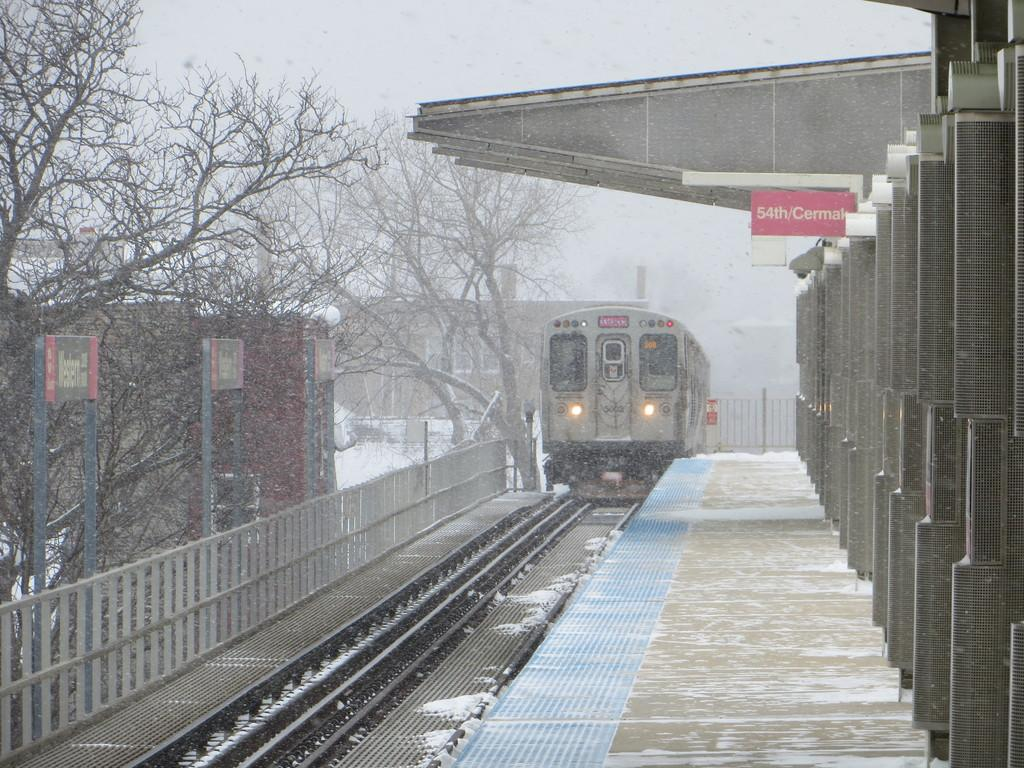Provide a one-sentence caption for the provided image. The train rides into snowy train station in the dead of winter. 